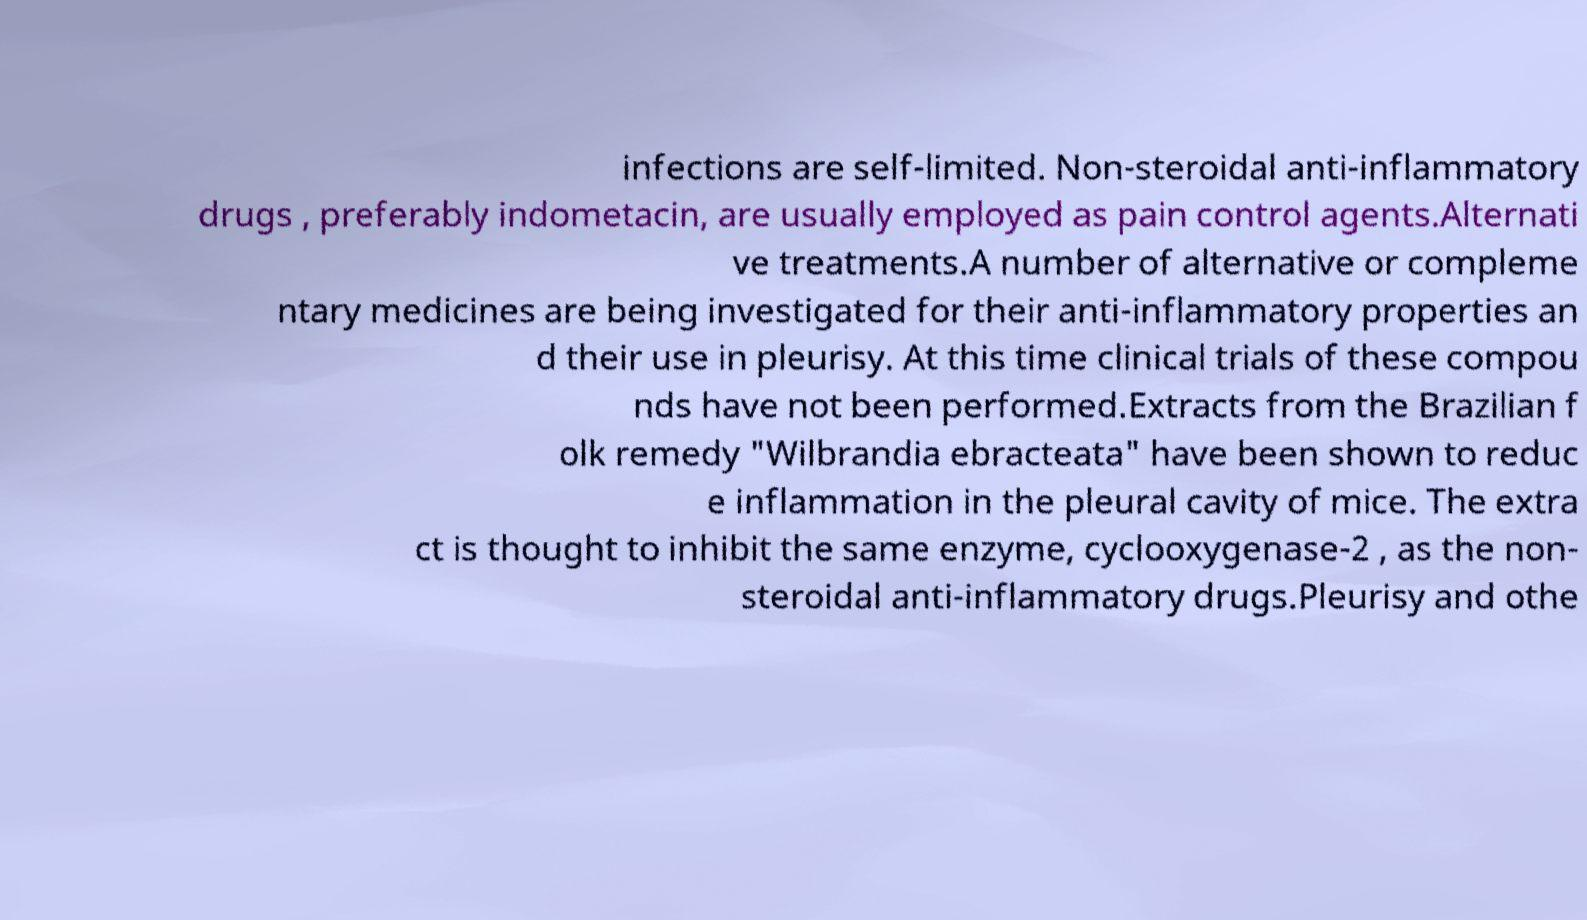Can you accurately transcribe the text from the provided image for me? infections are self-limited. Non-steroidal anti-inflammatory drugs , preferably indometacin, are usually employed as pain control agents.Alternati ve treatments.A number of alternative or compleme ntary medicines are being investigated for their anti-inflammatory properties an d their use in pleurisy. At this time clinical trials of these compou nds have not been performed.Extracts from the Brazilian f olk remedy "Wilbrandia ebracteata" have been shown to reduc e inflammation in the pleural cavity of mice. The extra ct is thought to inhibit the same enzyme, cyclooxygenase-2 , as the non- steroidal anti-inflammatory drugs.Pleurisy and othe 